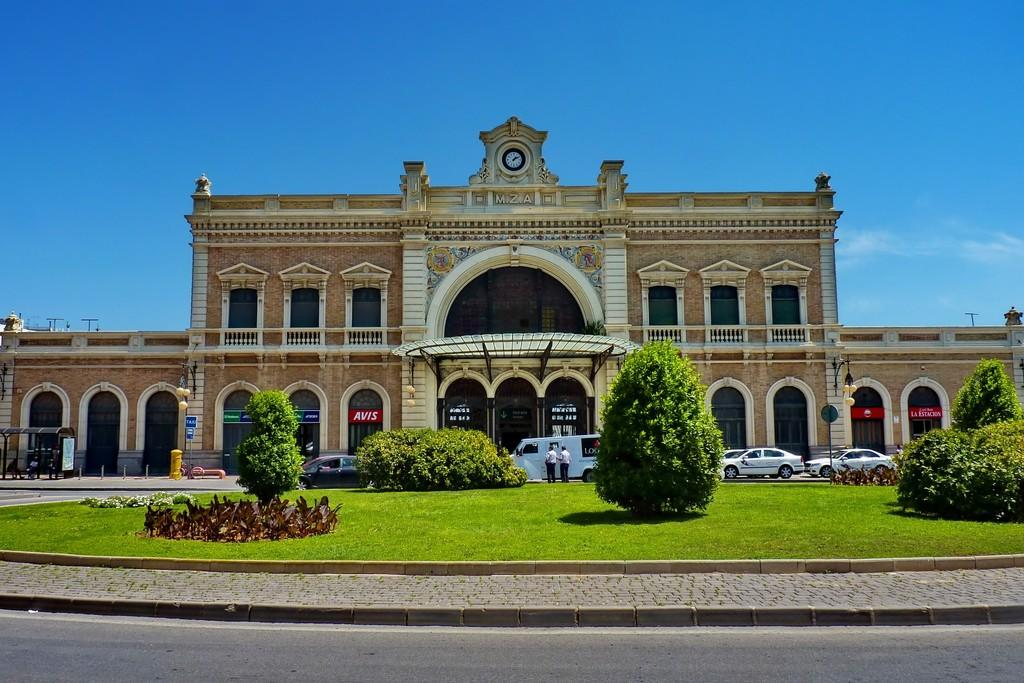Provide a one-sentence caption for the provided image. A huge building with the letters MZA on it has cars in front of it. 